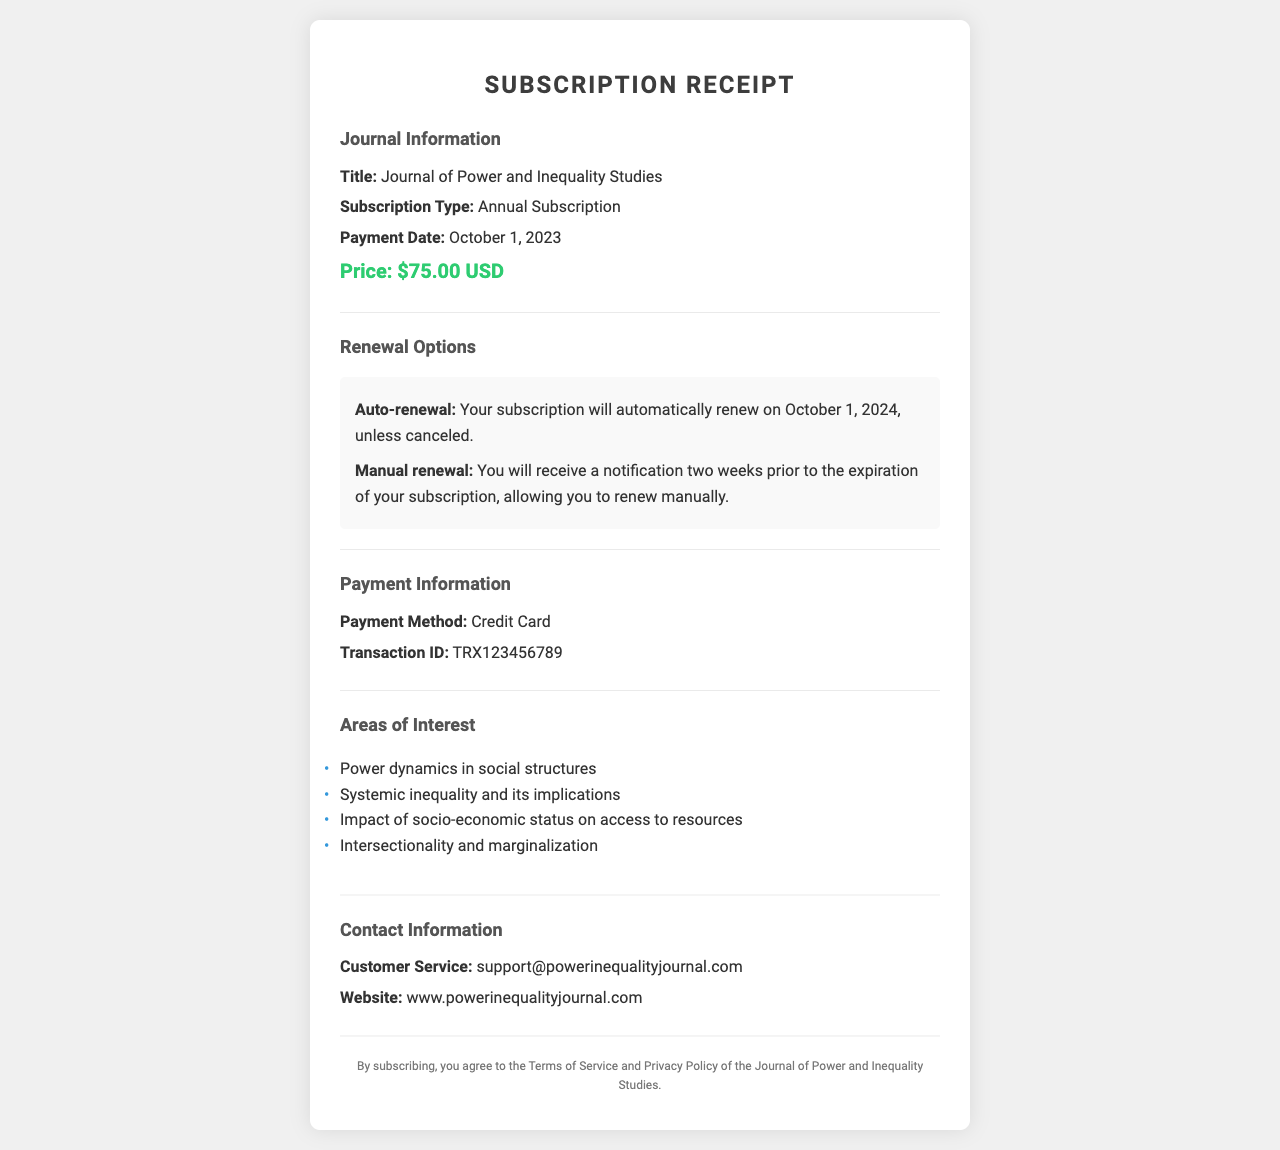What is the title of the journal? The title of the journal is explicitly mentioned in the document as part of the journal information section.
Answer: Journal of Power and Inequality Studies What is the price of the subscription? The price of the subscription is stated clearly in the document under the journal information section.
Answer: $75.00 USD When is the payment date? The payment date is listed in the journal information section of the receipt.
Answer: October 1, 2023 What type of subscription is it? The type of subscription is categorized in the journal information section of the receipt.
Answer: Annual Subscription What is the auto-renewal date? The auto-renewal date is specified within the renewal options section of the document.
Answer: October 1, 2024 How will I be notified of manual renewal? The process for notification is mentioned in the renewal options section of the document.
Answer: Two weeks prior to expiration What is the customer service email? The customer service email is provided under the contact information section of the document.
Answer: support@powerinequalityjournal.com What payment method was used? The payment method is explicitly stated in the payment information section of the receipt.
Answer: Credit Card What transaction ID is listed? The transaction ID is provided in the payment information section of the document.
Answer: TRX123456789 